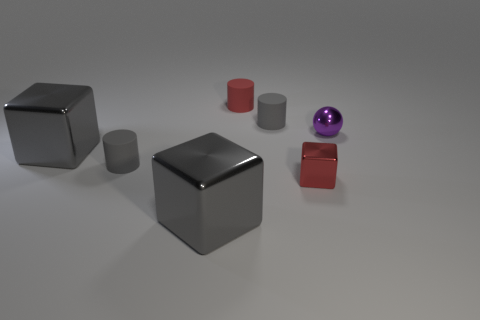There is a tiny cylinder that is the same color as the small block; what is it made of?
Ensure brevity in your answer.  Rubber. There is a red thing behind the sphere; is its size the same as the small metallic cube?
Your answer should be compact. Yes. Is there any other thing that is the same size as the red rubber thing?
Give a very brief answer. Yes. Is the purple metallic object the same shape as the red matte object?
Offer a very short reply. No. Is the number of tiny purple metal objects that are on the left side of the tiny block less than the number of tiny purple balls to the right of the small sphere?
Make the answer very short. No. How many small red rubber cylinders are to the left of the small red metallic cube?
Give a very brief answer. 1. There is a rubber object to the right of the small red cylinder; is it the same shape as the red thing that is in front of the small purple shiny thing?
Your answer should be very brief. No. What number of other things are the same color as the tiny cube?
Offer a terse response. 1. What material is the gray object that is right of the matte object behind the small gray cylinder behind the small purple object made of?
Your answer should be compact. Rubber. What material is the large block that is in front of the tiny shiny object that is left of the purple thing?
Provide a succinct answer. Metal. 